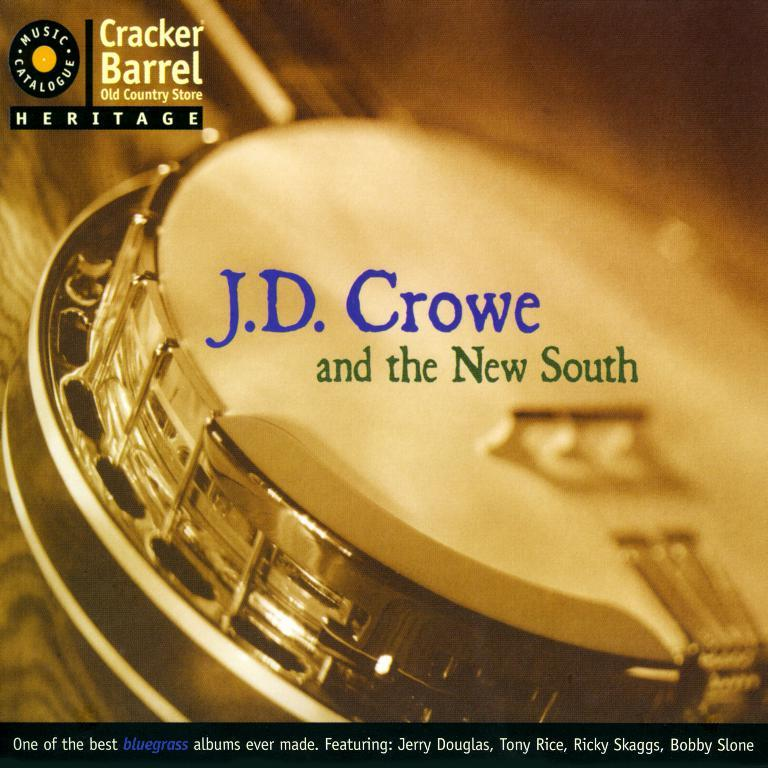<image>
Render a clear and concise summary of the photo. A banjo is on the cover of an album titled J.D. Crowe and the new south. 